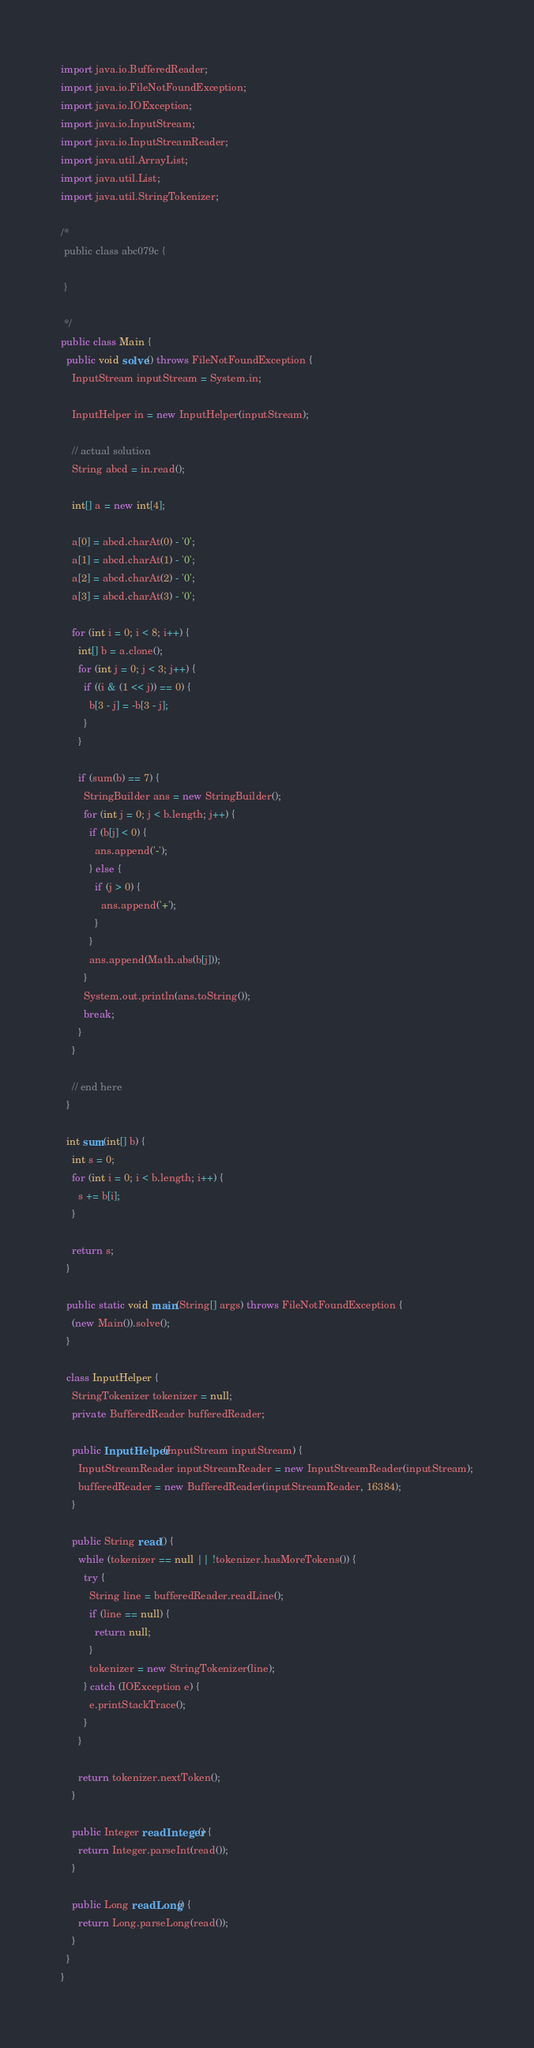<code> <loc_0><loc_0><loc_500><loc_500><_Java_>import java.io.BufferedReader;
import java.io.FileNotFoundException;
import java.io.IOException;
import java.io.InputStream;
import java.io.InputStreamReader;
import java.util.ArrayList;
import java.util.List;
import java.util.StringTokenizer;

/*
 public class abc079c {

 }

 */
public class Main {
  public void solve() throws FileNotFoundException {
    InputStream inputStream = System.in;

    InputHelper in = new InputHelper(inputStream);

    // actual solution
    String abcd = in.read();

    int[] a = new int[4];

    a[0] = abcd.charAt(0) - '0';
    a[1] = abcd.charAt(1) - '0';
    a[2] = abcd.charAt(2) - '0';
    a[3] = abcd.charAt(3) - '0';

    for (int i = 0; i < 8; i++) {
      int[] b = a.clone();
      for (int j = 0; j < 3; j++) {
        if ((i & (1 << j)) == 0) {
          b[3 - j] = -b[3 - j];
        }
      }

      if (sum(b) == 7) {
        StringBuilder ans = new StringBuilder();
        for (int j = 0; j < b.length; j++) {
          if (b[j] < 0) {
            ans.append('-');
          } else {
            if (j > 0) {
              ans.append('+');
            }
          }
          ans.append(Math.abs(b[j]));
        }
        System.out.println(ans.toString());
        break;
      }
    }

    // end here
  }

  int sum(int[] b) {
    int s = 0;
    for (int i = 0; i < b.length; i++) {
      s += b[i];
    }

    return s;
  }

  public static void main(String[] args) throws FileNotFoundException {
    (new Main()).solve();
  }

  class InputHelper {
    StringTokenizer tokenizer = null;
    private BufferedReader bufferedReader;

    public InputHelper(InputStream inputStream) {
      InputStreamReader inputStreamReader = new InputStreamReader(inputStream);
      bufferedReader = new BufferedReader(inputStreamReader, 16384);
    }

    public String read() {
      while (tokenizer == null || !tokenizer.hasMoreTokens()) {
        try {
          String line = bufferedReader.readLine();
          if (line == null) {
            return null;
          }
          tokenizer = new StringTokenizer(line);
        } catch (IOException e) {
          e.printStackTrace();
        }
      }

      return tokenizer.nextToken();
    }

    public Integer readInteger() {
      return Integer.parseInt(read());
    }

    public Long readLong() {
      return Long.parseLong(read());
    }
  }
}
</code> 